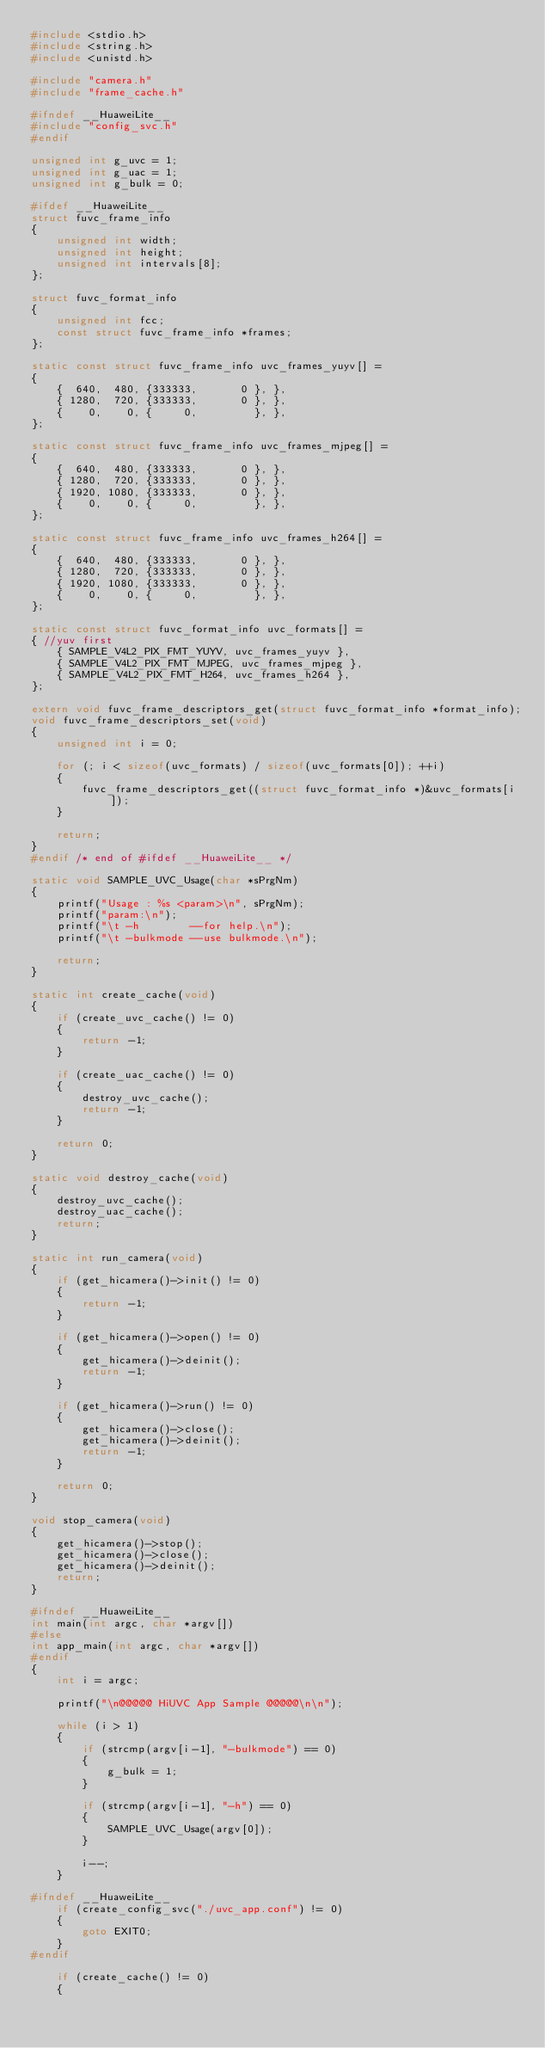Convert code to text. <code><loc_0><loc_0><loc_500><loc_500><_C_>#include <stdio.h>
#include <string.h>
#include <unistd.h>

#include "camera.h"
#include "frame_cache.h"

#ifndef __HuaweiLite__
#include "config_svc.h"
#endif

unsigned int g_uvc = 1;
unsigned int g_uac = 1;
unsigned int g_bulk = 0;

#ifdef __HuaweiLite__
struct fuvc_frame_info
{
    unsigned int width;
    unsigned int height;
    unsigned int intervals[8];
};

struct fuvc_format_info
{
    unsigned int fcc;
    const struct fuvc_frame_info *frames;
};

static const struct fuvc_frame_info uvc_frames_yuyv[] =
{
    {  640,  480, {333333,       0 }, },
    { 1280,  720, {333333,       0 }, },
    {    0,    0, {     0,         }, },
};

static const struct fuvc_frame_info uvc_frames_mjpeg[] =
{
    {  640,  480, {333333,       0 }, },
    { 1280,  720, {333333,       0 }, },
    { 1920, 1080, {333333,       0 }, },
    {    0,    0, {     0,         }, },
};

static const struct fuvc_frame_info uvc_frames_h264[] =
{
    {  640,  480, {333333,       0 }, },
    { 1280,  720, {333333,       0 }, },
    { 1920, 1080, {333333,       0 }, },
    {    0,    0, {     0,         }, },
};

static const struct fuvc_format_info uvc_formats[] =
{ //yuv first
    { SAMPLE_V4L2_PIX_FMT_YUYV, uvc_frames_yuyv },
    { SAMPLE_V4L2_PIX_FMT_MJPEG, uvc_frames_mjpeg },
    { SAMPLE_V4L2_PIX_FMT_H264, uvc_frames_h264 },
};

extern void fuvc_frame_descriptors_get(struct fuvc_format_info *format_info);
void fuvc_frame_descriptors_set(void)
{
    unsigned int i = 0;

    for (; i < sizeof(uvc_formats) / sizeof(uvc_formats[0]); ++i)
    {
        fuvc_frame_descriptors_get((struct fuvc_format_info *)&uvc_formats[i]);
    }

    return;
}
#endif /* end of #ifdef __HuaweiLite__ */

static void SAMPLE_UVC_Usage(char *sPrgNm)
{
    printf("Usage : %s <param>\n", sPrgNm);
    printf("param:\n");
    printf("\t -h        --for help.\n");
    printf("\t -bulkmode --use bulkmode.\n");

    return;
}

static int create_cache(void)
{
    if (create_uvc_cache() != 0)
    {
        return -1;
    }

    if (create_uac_cache() != 0)
    {
        destroy_uvc_cache();
        return -1;
    }

    return 0;
}

static void destroy_cache(void)
{
    destroy_uvc_cache();
    destroy_uac_cache();
    return;
}

static int run_camera(void)
{
    if (get_hicamera()->init() != 0)
    {
        return -1;
    }

    if (get_hicamera()->open() != 0)
    {
        get_hicamera()->deinit();
        return -1;
    }

    if (get_hicamera()->run() != 0)
    {
        get_hicamera()->close();
        get_hicamera()->deinit();
        return -1;
    }

    return 0;
}

void stop_camera(void)
{
    get_hicamera()->stop();
    get_hicamera()->close();
    get_hicamera()->deinit();
    return;
}

#ifndef __HuaweiLite__
int main(int argc, char *argv[])
#else
int app_main(int argc, char *argv[])
#endif
{
    int i = argc;

    printf("\n@@@@@ HiUVC App Sample @@@@@\n\n");

    while (i > 1)
    {
        if (strcmp(argv[i-1], "-bulkmode") == 0)
        {
            g_bulk = 1;
        }

        if (strcmp(argv[i-1], "-h") == 0)
        {
            SAMPLE_UVC_Usage(argv[0]);
        }

        i--;
    }

#ifndef __HuaweiLite__
    if (create_config_svc("./uvc_app.conf") != 0)
    {
        goto EXIT0;
    }
#endif

    if (create_cache() != 0)
    {</code> 